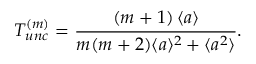Convert formula to latex. <formula><loc_0><loc_0><loc_500><loc_500>T _ { u n c } ^ { ( m ) } = \frac { \left ( m + 1 \right ) \langle a \rangle } { m ( m + 2 ) \langle a \rangle ^ { 2 } + \langle a ^ { 2 } \rangle } .</formula> 